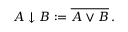<formula> <loc_0><loc_0><loc_500><loc_500>\begin{array} { r } { A \downarrow B \colon = \overline { A \vee B } \, . } \end{array}</formula> 